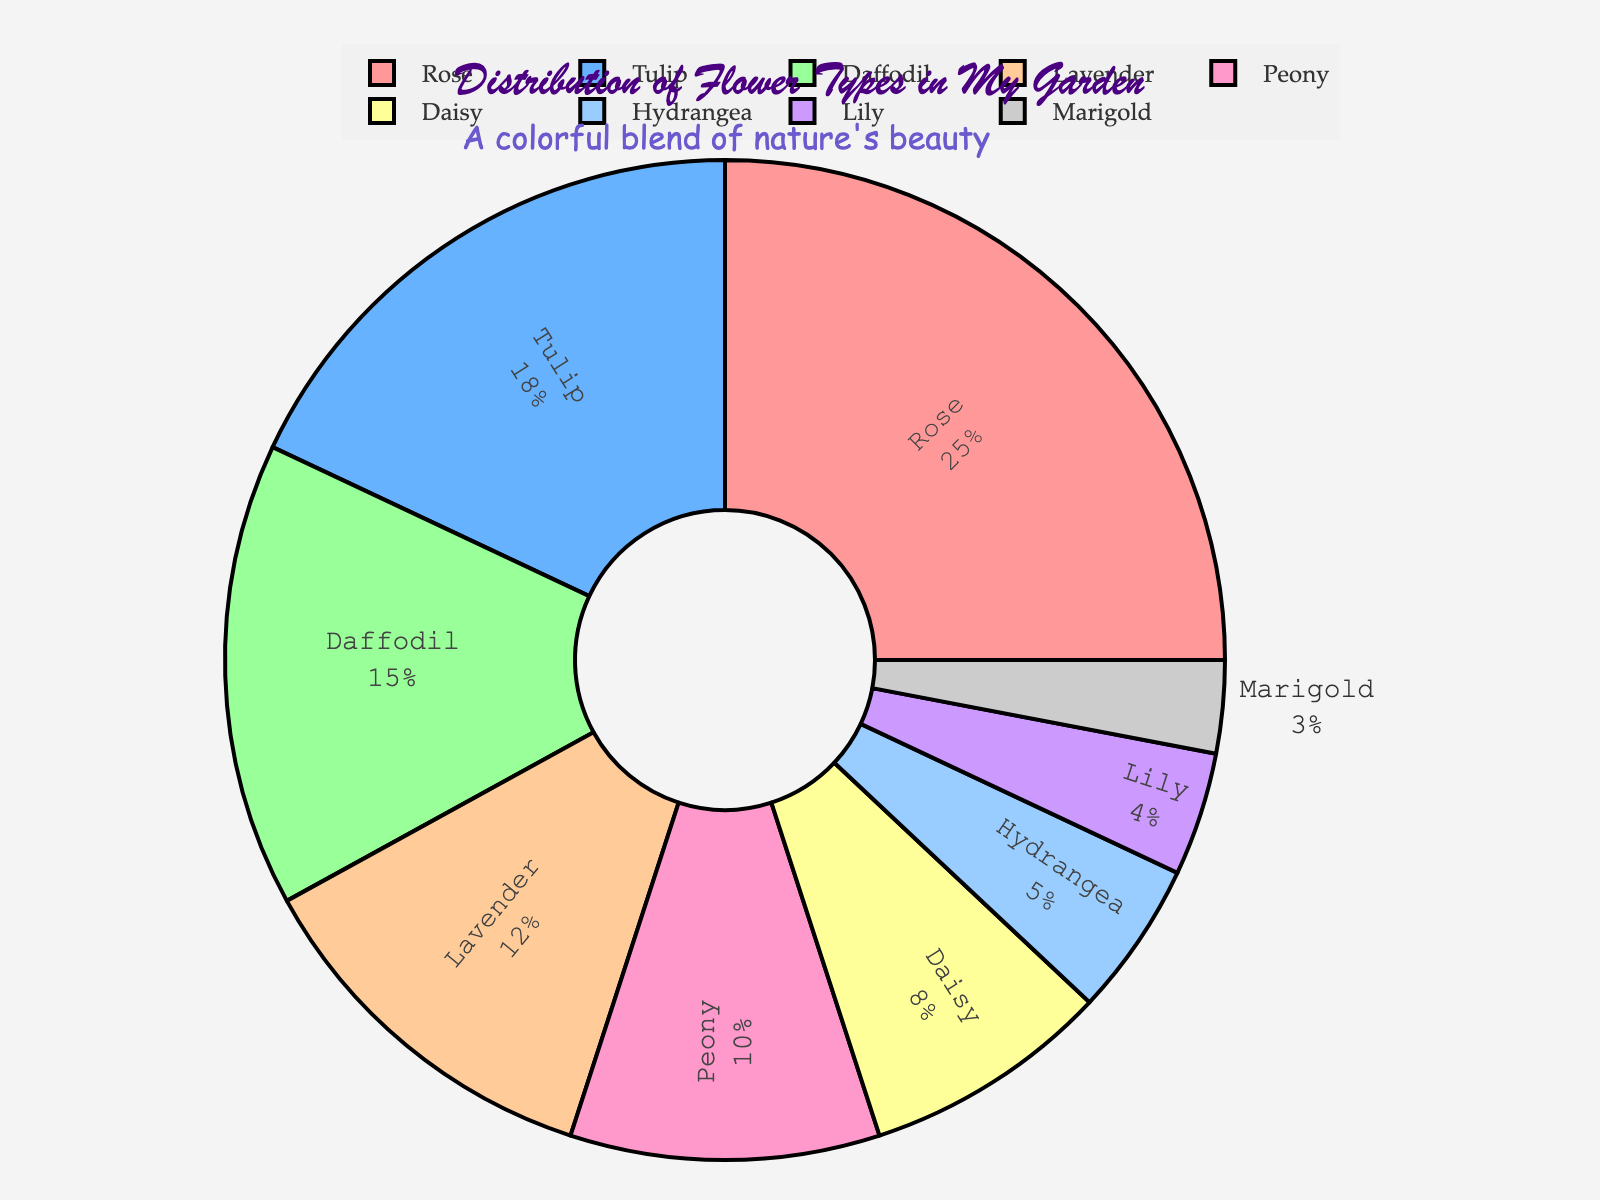Which flower type has the highest percentage in the garden? The pie chart shows that Roses occupy the largest portion of the pie. This indicates that Roses have the highest percentage among all flower types listed.
Answer: Rose Which flower type has the smallest percentage in the garden? The smallest segment of the pie chart represents Marigolds, indicating they have the smallest percentage.
Answer: Marigold Are there more Tulips or Peonies in the garden? By comparing the sizes of the segments in the pie chart, we see that the Tulip segment is larger than the Peony segment. Therefore, there are more Tulips than Peonies.
Answer: Tulip What is the total percentage of Lavender and Daisy combined? To find the total percentage of Lavender and Daisy, we sum their individual percentages which are 12% for Lavender and 8% for Daisy. Therefore, 12 + 8 = 20%.
Answer: 20% How many times larger is the percentage of Roses compared to the percentage of Marigolds? The percentage for Roses is 25%, whereas for Marigolds it is 3%. To find how many times larger, divide 25 by 3. 25 / 3 = 8.33 (approximately).
Answer: 8.33 times Which two flower types have a combined percentage equal to that of Roses? The percentage for Roses is 25%. By looking at the chart, we can find that Tulips (18%) + Lilies (4%) = 18 + 4 = 22% which is closest but not equal. However, Tulips (18%) + Daffodils (15%) = 33% which exceeds Roses. Lavender (12%) + Peony (10%) = 22% which again is closest but not equal. The percentages don't exactly equal 25% but come close.
Answer: None exactly Which flower types have a greater percentage than Daffodil? The pie chart segments indicate that the flower types with higher percentages than Daffodil, which is at 15%, are Roses (25%) and Tulips (18%).
Answer: Rose, Tulip What's the average percentage of the non-Rose flower types? First, sum the percentages of all non-Rose flower types: Tulip (18%) + Daffodil (15%) + Lavender (12%) + Peony (10%) + Daisy (8%) + Hydrangea (5%) + Lily (4%) + Marigold (3%) = 75. Then, divide by the number of non-Rose flower types: 75 / 8 = 9.375%.
Answer: 9.375% 